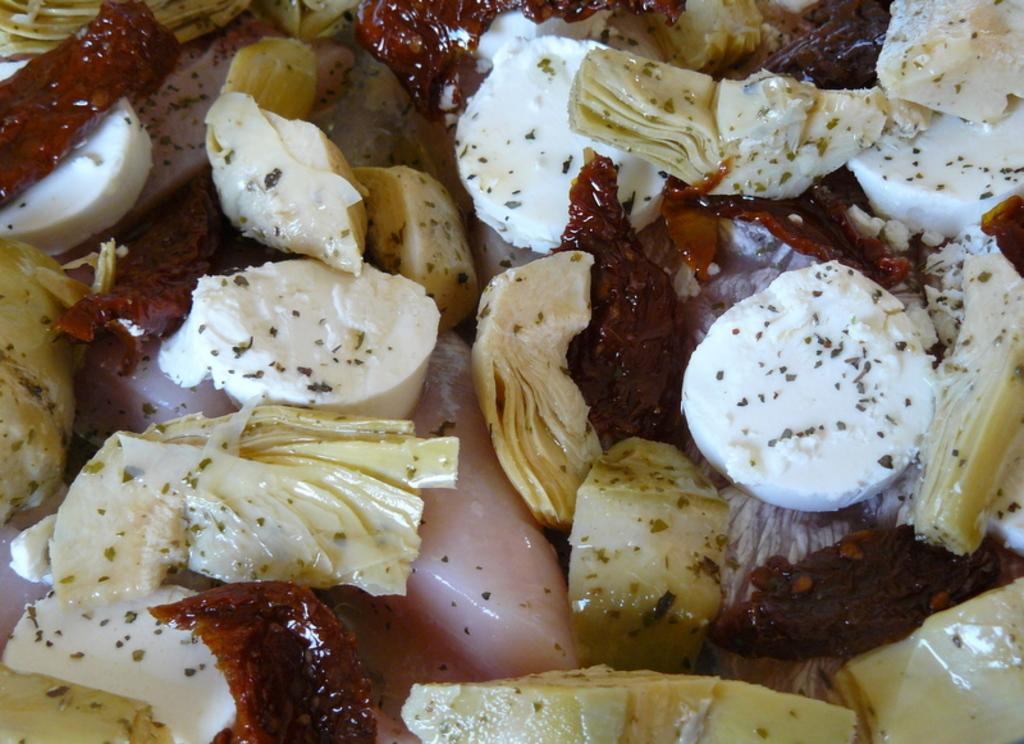What type of dish is featured in the image? There is a salad in the image. What ingredients can be found in the salad? The salad contains meat, cabbage pieces, cheese, and red chilies. How is the salad prepared? The salad is garnished with seasoning. What type of flag is waving in the background of the image? There is no flag present in the image; it features a salad with various ingredients and garnish. 